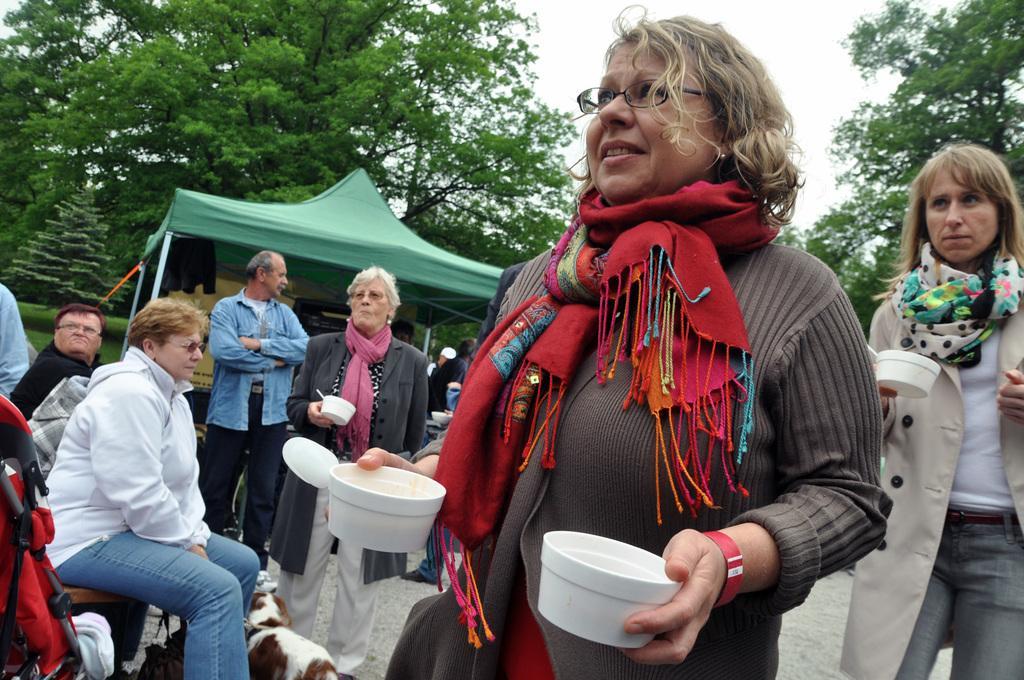Can you describe this image briefly? In this picture we can see group of people were in front woman wore spectacle, scarf holding balls in her hand and in the background we can see tent, tree, sky. 